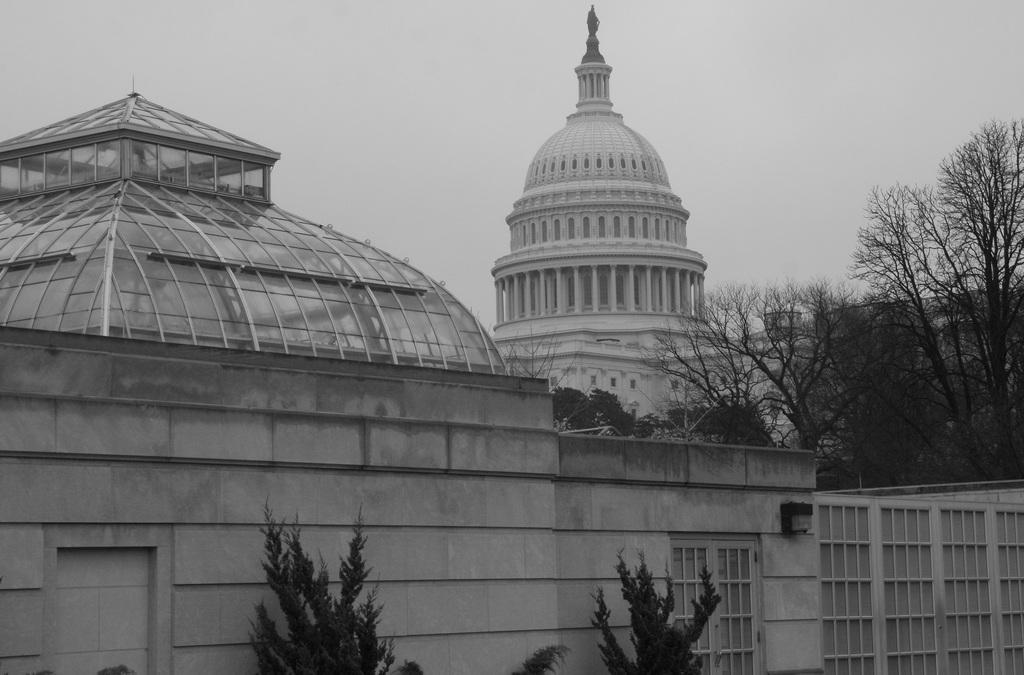What is the color scheme of the image? The image is black and white. What type of structures can be seen in the image? There are buildings with pillars in the image. What architectural element is present in the image? There is a wall in the image. What type of natural elements are present in the image? There are many trees in the image. What can be seen in the background of the image? The sky is visible in the background of the image. What type of shirt is the writer wearing in the image? There is no writer or shirt present in the image; it is a black and white image featuring buildings, a wall, trees, and the sky. 